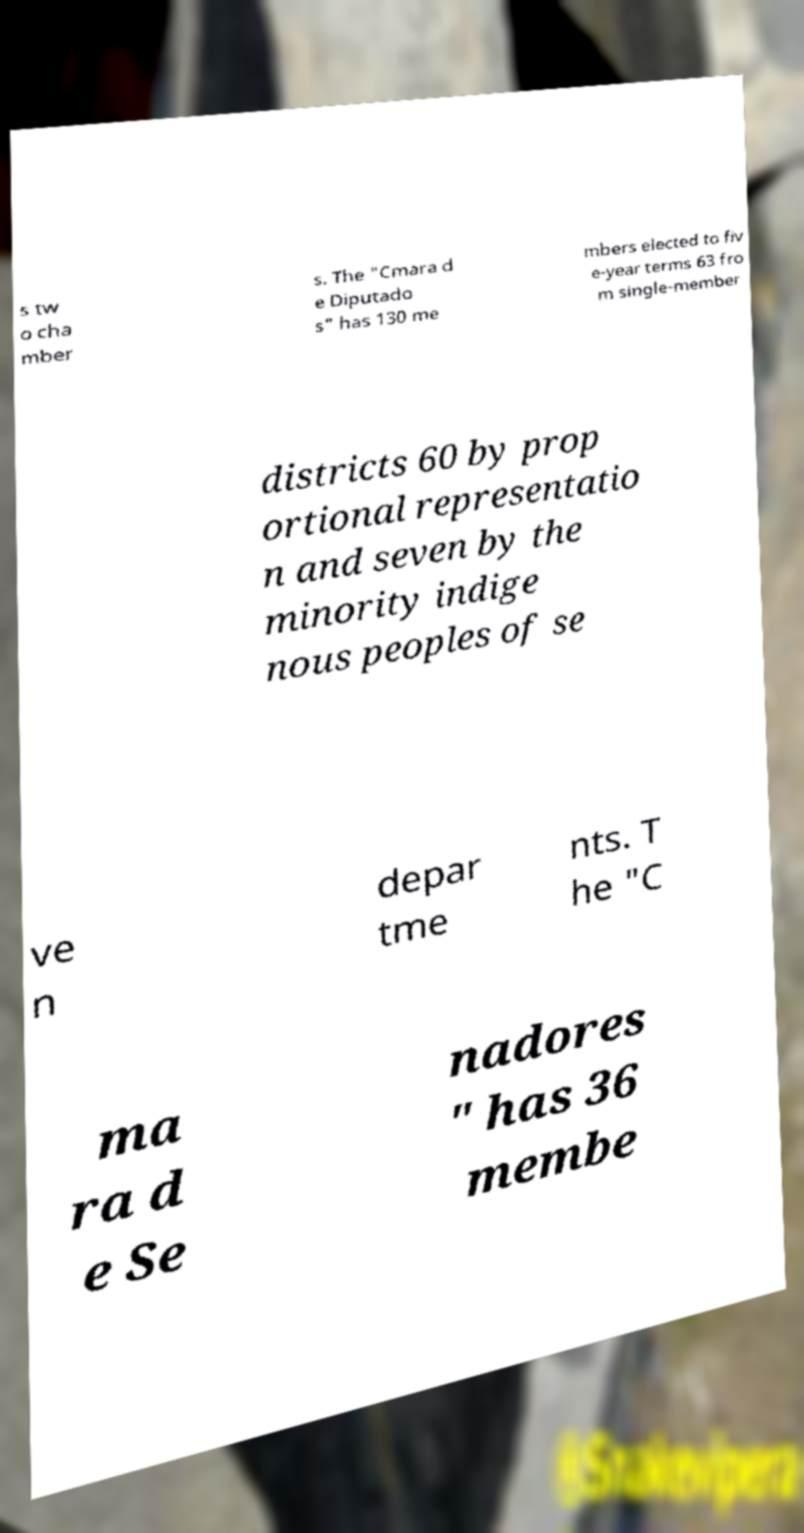What messages or text are displayed in this image? I need them in a readable, typed format. s tw o cha mber s. The "Cmara d e Diputado s" has 130 me mbers elected to fiv e-year terms 63 fro m single-member districts 60 by prop ortional representatio n and seven by the minority indige nous peoples of se ve n depar tme nts. T he "C ma ra d e Se nadores " has 36 membe 